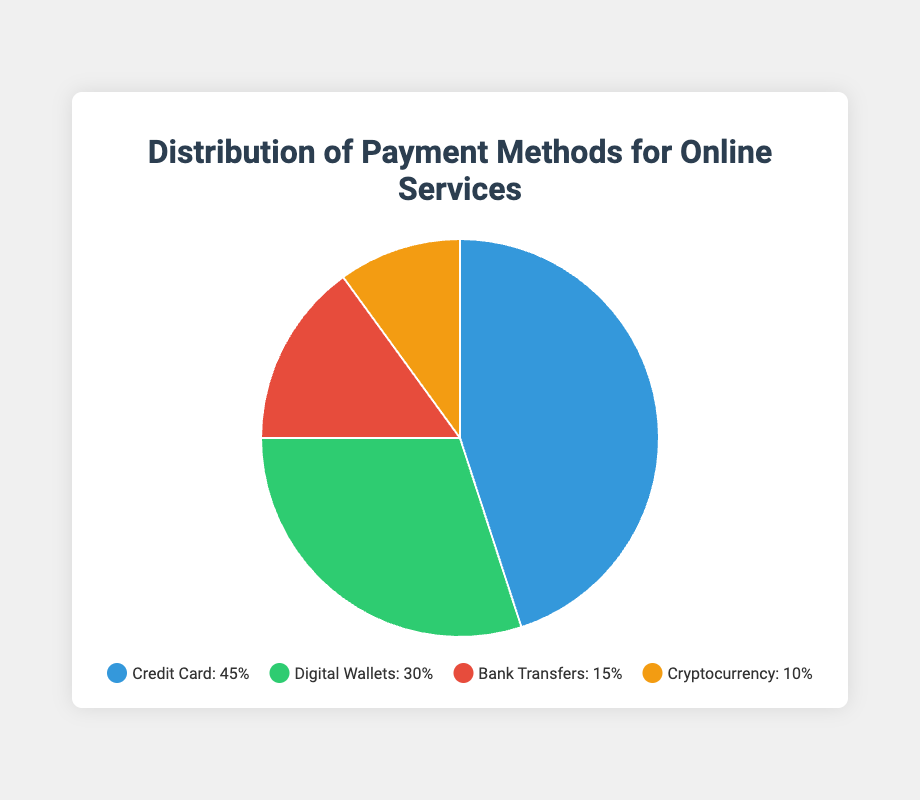Are Digital Wallets more or less popular than Bank Transfers? Digital Wallets represent 30% of the distribution, while Bank Transfers represent 15%. Since 30% is greater than 15%, Digital Wallets are more popular than Bank Transfers.
Answer: More What’s the difference in percentage between Credit Cards and Cryptocurrency? Credit Cards account for 45% and Cryptocurrency accounts for 10%. The difference is 45% - 10% = 35%.
Answer: 35% Which payment method is the least popular? Cryptocurrency has the lowest percentage, at 10%.
Answer: Cryptocurrency What’s the combined percentage of non-cash alternatives (Digital Wallets, Bank Transfers, Cryptocurrency)? The combined percentage is the sum of Digital Wallets (30%), Bank Transfers (15%), and Cryptocurrency (10%). So, 30% + 15% + 10% = 55%.
Answer: 55% What color represents Bank Transfers? The legend shows that Bank Transfers are represented by the red color.
Answer: Red Is the sum of the percentages for Credit Cards and Bank Transfers greater than 50%? Credit Cards account for 45% and Bank Transfers account for 15%. The sum is 45% + 15% = 60%, which is greater than 50%.
Answer: Yes Which two payment methods together make up less than half of the total distribution? Bank Transfers (15%) and Cryptocurrency (10%) together sum up to 25%, which is less than 50%.
Answer: Bank Transfers and Cryptocurrency What is the average percentage of the four payment methods? The total percentage is 100%. The number of payment methods is 4. The average is 100% / 4 = 25%.
Answer: 25% What proportion of the chart is taken up by Digital Wallets? Digital Wallets account for 30% of the chart.
Answer: 30% 